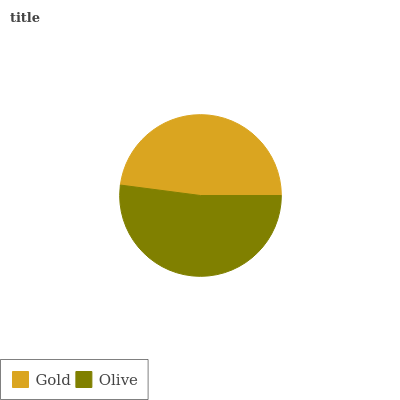Is Gold the minimum?
Answer yes or no. Yes. Is Olive the maximum?
Answer yes or no. Yes. Is Olive the minimum?
Answer yes or no. No. Is Olive greater than Gold?
Answer yes or no. Yes. Is Gold less than Olive?
Answer yes or no. Yes. Is Gold greater than Olive?
Answer yes or no. No. Is Olive less than Gold?
Answer yes or no. No. Is Olive the high median?
Answer yes or no. Yes. Is Gold the low median?
Answer yes or no. Yes. Is Gold the high median?
Answer yes or no. No. Is Olive the low median?
Answer yes or no. No. 